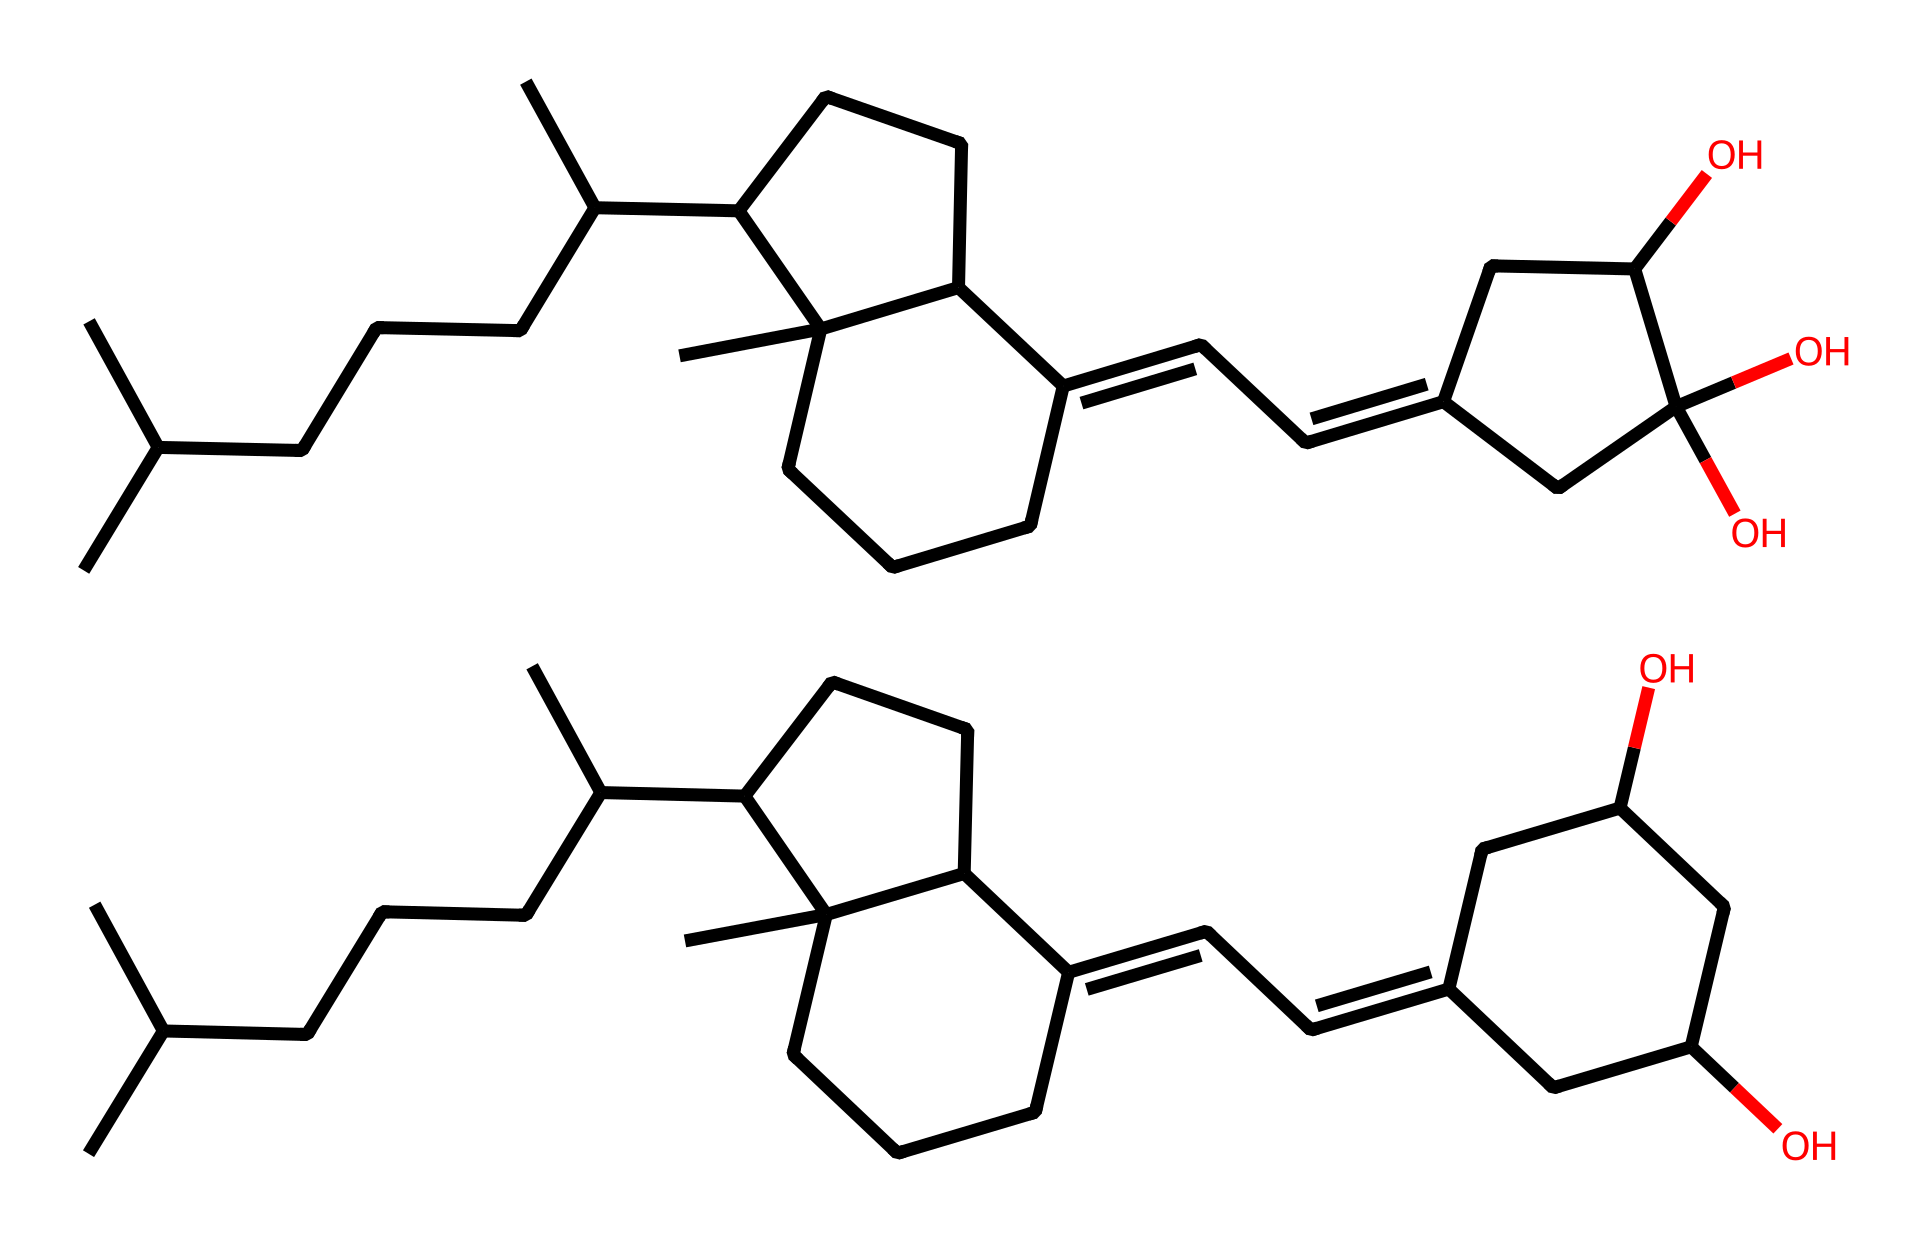What is the molecular formula for vitamin D3 represented in the SMILES? By analyzing the SMILES representation, we can identify the number of carbon (C), hydrogen (H), and oxygen (O) atoms present. In this case, we count 27 carbon atoms, 44 hydrogen atoms, and 2 oxygen atoms, resulting in the molecular formula C27H44O2.
Answer: C27H44O2 How many rings are present in the structure of vitamin D3? In the SMILES representation, we can identify the presence of cycloalkane structures that indicate rings. There are two cyclohexane rings and one additional cyclopentene ring present, totaling three rings.
Answer: 3 What is the significance of the hydroxyl groups in vitamin D3? The two hydroxyl (-OH) groups present in the structure make vitamin D3 a secosteroid, playing a critical role in its biological activity as they are involved in receptor binding and the activation of vitamin D.
Answer: secosteroid What are the functional groups present in vitamin D3? Analyzing the structure, the primary functional groups are hydroxyl groups (-OH) and a secosteroid backbone. These groups participate in the biological activity of vitamin D3, which is essential for calcium metabolism.
Answer: hydroxyl groups How many double bonds are present in vitamin D3? Examining the rings and carbon chain in the chemical structure, we can identify three double bonds (as indicated by unsaturation in the SMILES). These contribute to the chemical's biological function and properties.
Answer: 3 In which organ does the conversion of vitamin D3 to its active form primarily occur? The conversion of vitamin D3 into its active form, calcitriol, primarily takes place in the kidneys after it is metabolized in the liver first. This organ's role is crucial for maintaining calcium and phosphate balance in the body.
Answer: kidneys 